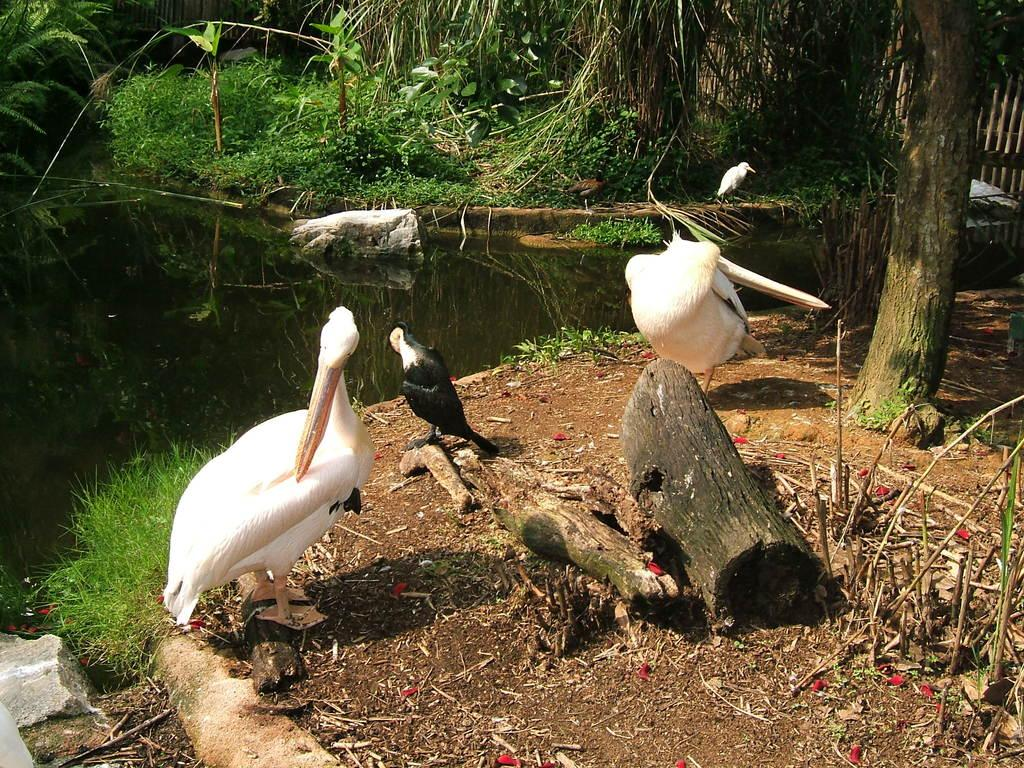What animals are in the center of the image? There are ducks in the center of the image. What type of vegetation or plants can be seen at the top side of the image? There is greenery at the top side of the image. Where is the drawer located in the image? There is no drawer present in the image. Can you see a mitten on any of the ducks in the image? There are no mittens present on the ducks in the image. 